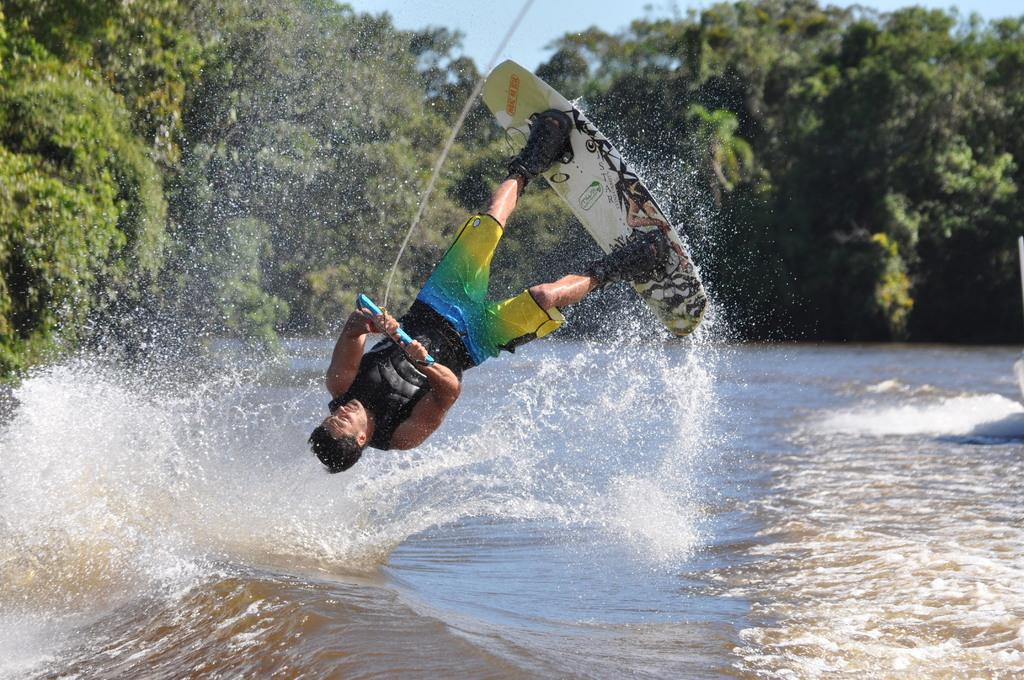Who is present in the image? There is a man in the image. What is the man doing in the image? The man is diving in the image. What is the primary setting of the image? There is water in the image. What can be seen in the background of the image? There are trees in the image. What organization is responsible for maintaining the rest area in the image? There is no rest area present in the image, so it is not possible to determine which organization might be responsible for maintaining it. 